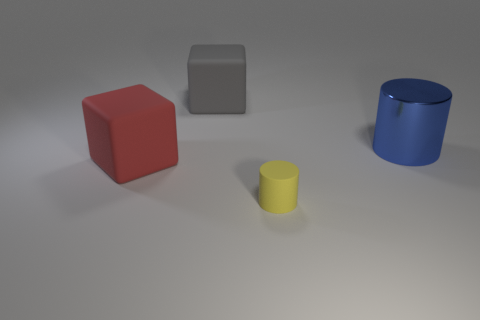Add 3 tiny brown objects. How many objects exist? 7 Add 3 purple rubber blocks. How many purple rubber blocks exist? 3 Subtract 0 yellow blocks. How many objects are left? 4 Subtract all small brown metal objects. Subtract all big cubes. How many objects are left? 2 Add 1 large gray blocks. How many large gray blocks are left? 2 